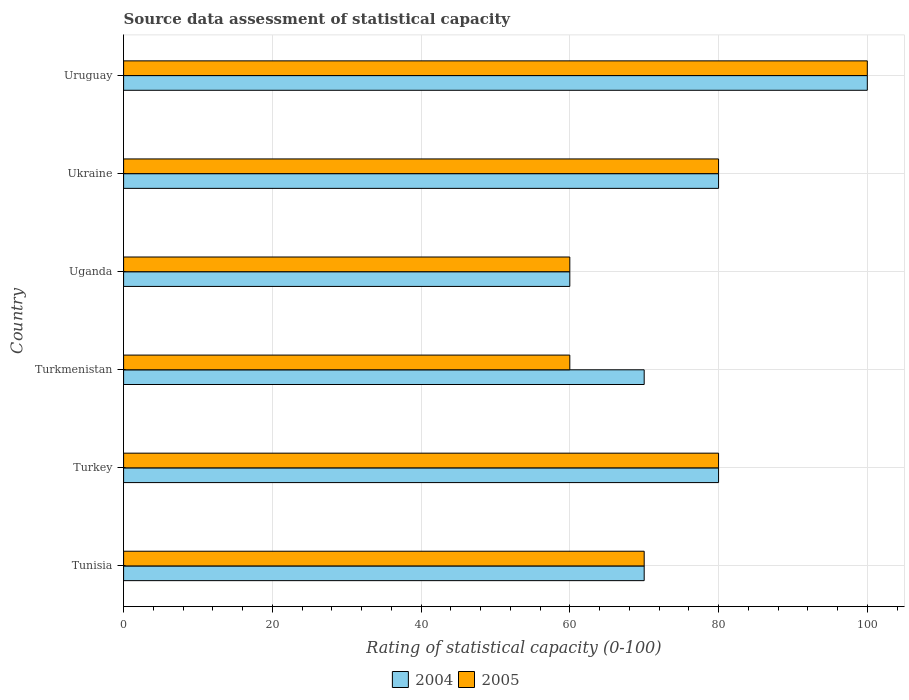How many groups of bars are there?
Your answer should be very brief. 6. Are the number of bars per tick equal to the number of legend labels?
Keep it short and to the point. Yes. Are the number of bars on each tick of the Y-axis equal?
Provide a succinct answer. Yes. How many bars are there on the 6th tick from the top?
Your answer should be very brief. 2. What is the label of the 3rd group of bars from the top?
Offer a terse response. Uganda. Across all countries, what is the minimum rating of statistical capacity in 2005?
Provide a short and direct response. 60. In which country was the rating of statistical capacity in 2005 maximum?
Provide a succinct answer. Uruguay. In which country was the rating of statistical capacity in 2005 minimum?
Your answer should be very brief. Turkmenistan. What is the total rating of statistical capacity in 2005 in the graph?
Give a very brief answer. 450. What is the difference between the rating of statistical capacity in 2004 in Turkmenistan and that in Ukraine?
Provide a succinct answer. -10. What is the average rating of statistical capacity in 2005 per country?
Offer a terse response. 75. What is the ratio of the rating of statistical capacity in 2005 in Turkey to that in Turkmenistan?
Your response must be concise. 1.33. What is the difference between the highest and the lowest rating of statistical capacity in 2004?
Give a very brief answer. 40. In how many countries, is the rating of statistical capacity in 2004 greater than the average rating of statistical capacity in 2004 taken over all countries?
Your answer should be compact. 3. What does the 2nd bar from the bottom in Turkmenistan represents?
Provide a succinct answer. 2005. How many bars are there?
Offer a terse response. 12. Are all the bars in the graph horizontal?
Ensure brevity in your answer.  Yes. Does the graph contain grids?
Make the answer very short. Yes. How many legend labels are there?
Keep it short and to the point. 2. What is the title of the graph?
Your answer should be compact. Source data assessment of statistical capacity. What is the label or title of the X-axis?
Make the answer very short. Rating of statistical capacity (0-100). What is the Rating of statistical capacity (0-100) in 2004 in Tunisia?
Make the answer very short. 70. What is the Rating of statistical capacity (0-100) of 2004 in Turkey?
Ensure brevity in your answer.  80. What is the Rating of statistical capacity (0-100) in 2004 in Turkmenistan?
Offer a terse response. 70. What is the Rating of statistical capacity (0-100) in 2004 in Ukraine?
Your response must be concise. 80. What is the Rating of statistical capacity (0-100) of 2005 in Ukraine?
Ensure brevity in your answer.  80. Across all countries, what is the maximum Rating of statistical capacity (0-100) in 2004?
Your response must be concise. 100. What is the total Rating of statistical capacity (0-100) in 2004 in the graph?
Ensure brevity in your answer.  460. What is the total Rating of statistical capacity (0-100) of 2005 in the graph?
Your response must be concise. 450. What is the difference between the Rating of statistical capacity (0-100) of 2004 in Tunisia and that in Turkey?
Offer a terse response. -10. What is the difference between the Rating of statistical capacity (0-100) of 2005 in Tunisia and that in Turkey?
Your answer should be compact. -10. What is the difference between the Rating of statistical capacity (0-100) of 2004 in Tunisia and that in Turkmenistan?
Your answer should be very brief. 0. What is the difference between the Rating of statistical capacity (0-100) of 2004 in Tunisia and that in Uganda?
Keep it short and to the point. 10. What is the difference between the Rating of statistical capacity (0-100) of 2005 in Tunisia and that in Uganda?
Your answer should be very brief. 10. What is the difference between the Rating of statistical capacity (0-100) of 2004 in Tunisia and that in Ukraine?
Your answer should be very brief. -10. What is the difference between the Rating of statistical capacity (0-100) of 2004 in Tunisia and that in Uruguay?
Offer a terse response. -30. What is the difference between the Rating of statistical capacity (0-100) of 2005 in Tunisia and that in Uruguay?
Provide a short and direct response. -30. What is the difference between the Rating of statistical capacity (0-100) in 2004 in Turkey and that in Turkmenistan?
Provide a succinct answer. 10. What is the difference between the Rating of statistical capacity (0-100) of 2005 in Turkey and that in Turkmenistan?
Offer a very short reply. 20. What is the difference between the Rating of statistical capacity (0-100) of 2004 in Turkey and that in Uganda?
Offer a terse response. 20. What is the difference between the Rating of statistical capacity (0-100) of 2004 in Turkey and that in Ukraine?
Give a very brief answer. 0. What is the difference between the Rating of statistical capacity (0-100) of 2005 in Turkey and that in Uruguay?
Your answer should be very brief. -20. What is the difference between the Rating of statistical capacity (0-100) of 2005 in Turkmenistan and that in Uganda?
Give a very brief answer. 0. What is the difference between the Rating of statistical capacity (0-100) in 2005 in Turkmenistan and that in Ukraine?
Your response must be concise. -20. What is the difference between the Rating of statistical capacity (0-100) of 2004 in Turkmenistan and that in Uruguay?
Provide a short and direct response. -30. What is the difference between the Rating of statistical capacity (0-100) in 2005 in Turkmenistan and that in Uruguay?
Provide a succinct answer. -40. What is the difference between the Rating of statistical capacity (0-100) in 2005 in Uganda and that in Ukraine?
Make the answer very short. -20. What is the difference between the Rating of statistical capacity (0-100) of 2004 in Ukraine and that in Uruguay?
Your answer should be very brief. -20. What is the difference between the Rating of statistical capacity (0-100) in 2005 in Ukraine and that in Uruguay?
Offer a very short reply. -20. What is the difference between the Rating of statistical capacity (0-100) in 2004 in Tunisia and the Rating of statistical capacity (0-100) in 2005 in Uganda?
Provide a short and direct response. 10. What is the difference between the Rating of statistical capacity (0-100) of 2004 in Tunisia and the Rating of statistical capacity (0-100) of 2005 in Ukraine?
Ensure brevity in your answer.  -10. What is the difference between the Rating of statistical capacity (0-100) in 2004 in Turkey and the Rating of statistical capacity (0-100) in 2005 in Uruguay?
Offer a very short reply. -20. What is the difference between the Rating of statistical capacity (0-100) in 2004 in Turkmenistan and the Rating of statistical capacity (0-100) in 2005 in Uganda?
Your answer should be very brief. 10. What is the difference between the Rating of statistical capacity (0-100) in 2004 in Ukraine and the Rating of statistical capacity (0-100) in 2005 in Uruguay?
Your answer should be compact. -20. What is the average Rating of statistical capacity (0-100) of 2004 per country?
Provide a succinct answer. 76.67. What is the difference between the Rating of statistical capacity (0-100) of 2004 and Rating of statistical capacity (0-100) of 2005 in Tunisia?
Ensure brevity in your answer.  0. What is the difference between the Rating of statistical capacity (0-100) of 2004 and Rating of statistical capacity (0-100) of 2005 in Uruguay?
Your answer should be very brief. 0. What is the ratio of the Rating of statistical capacity (0-100) of 2005 in Tunisia to that in Turkey?
Offer a terse response. 0.88. What is the ratio of the Rating of statistical capacity (0-100) in 2004 in Tunisia to that in Turkmenistan?
Your answer should be compact. 1. What is the ratio of the Rating of statistical capacity (0-100) in 2005 in Tunisia to that in Turkmenistan?
Your response must be concise. 1.17. What is the ratio of the Rating of statistical capacity (0-100) in 2004 in Tunisia to that in Uganda?
Ensure brevity in your answer.  1.17. What is the ratio of the Rating of statistical capacity (0-100) of 2004 in Tunisia to that in Ukraine?
Offer a very short reply. 0.88. What is the ratio of the Rating of statistical capacity (0-100) of 2005 in Tunisia to that in Ukraine?
Keep it short and to the point. 0.88. What is the ratio of the Rating of statistical capacity (0-100) in 2004 in Tunisia to that in Uruguay?
Make the answer very short. 0.7. What is the ratio of the Rating of statistical capacity (0-100) in 2005 in Turkey to that in Ukraine?
Give a very brief answer. 1. What is the ratio of the Rating of statistical capacity (0-100) in 2005 in Turkey to that in Uruguay?
Give a very brief answer. 0.8. What is the ratio of the Rating of statistical capacity (0-100) of 2004 in Turkmenistan to that in Uganda?
Offer a very short reply. 1.17. What is the ratio of the Rating of statistical capacity (0-100) in 2004 in Turkmenistan to that in Uruguay?
Offer a very short reply. 0.7. What is the ratio of the Rating of statistical capacity (0-100) in 2004 in Uganda to that in Ukraine?
Give a very brief answer. 0.75. What is the ratio of the Rating of statistical capacity (0-100) in 2005 in Uganda to that in Ukraine?
Provide a succinct answer. 0.75. What is the ratio of the Rating of statistical capacity (0-100) of 2004 in Ukraine to that in Uruguay?
Your answer should be compact. 0.8. 